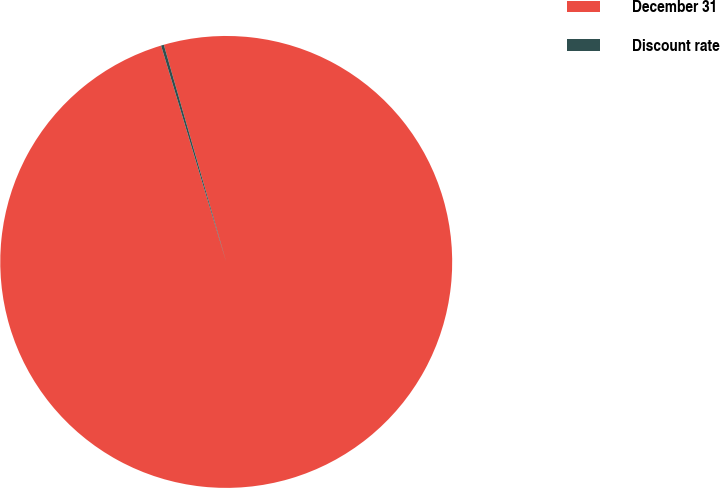Convert chart. <chart><loc_0><loc_0><loc_500><loc_500><pie_chart><fcel>December 31<fcel>Discount rate<nl><fcel>99.8%<fcel>0.2%<nl></chart> 